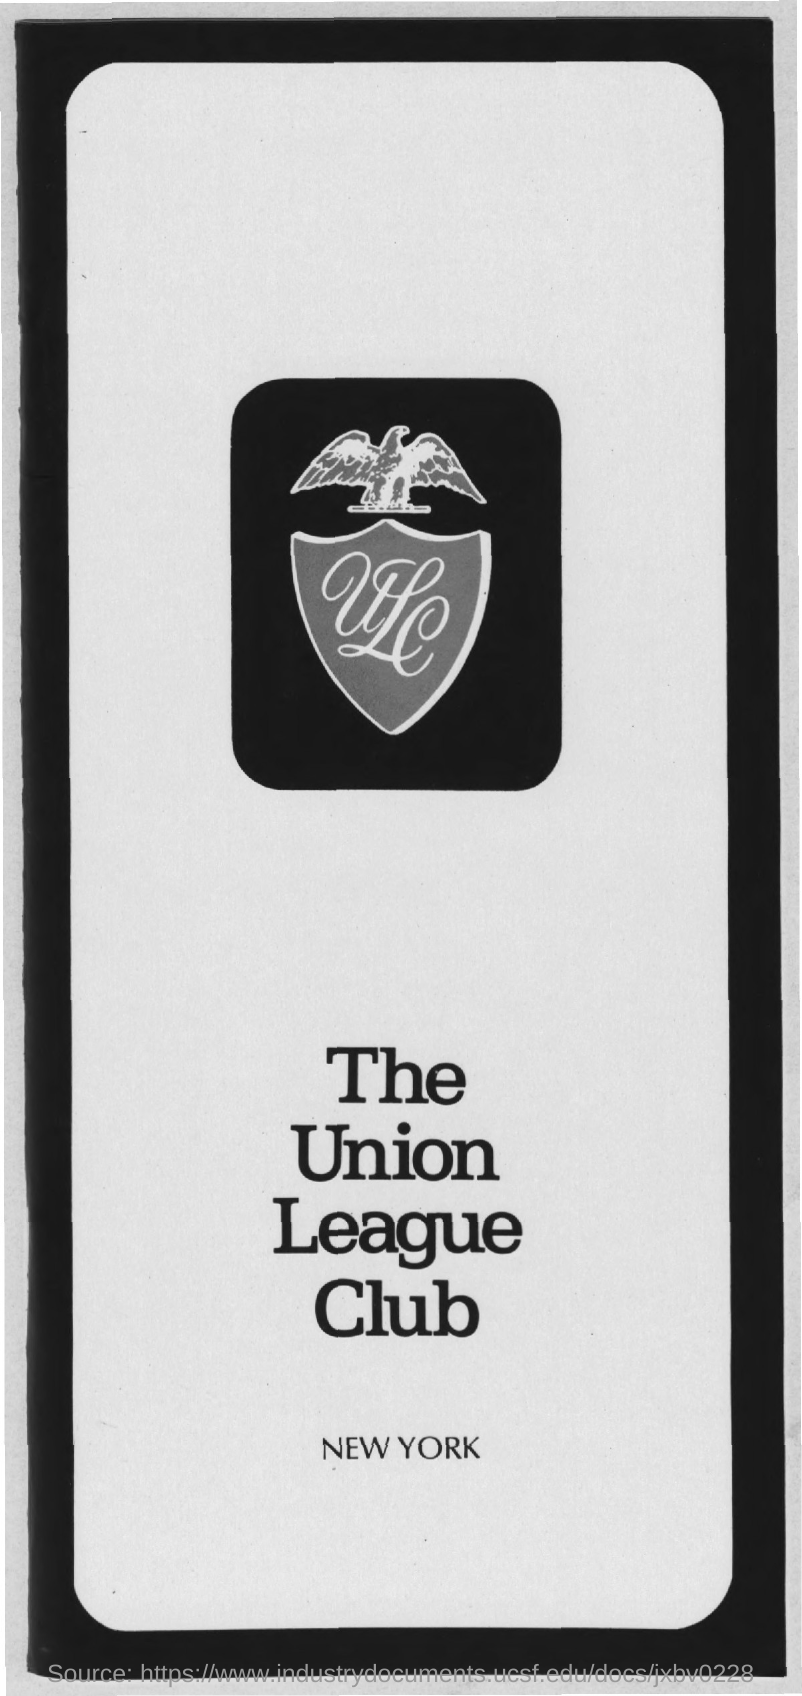What is the name of the club mentioned ?
Give a very brief answer. THE UNION LEAGUE CLUB. 